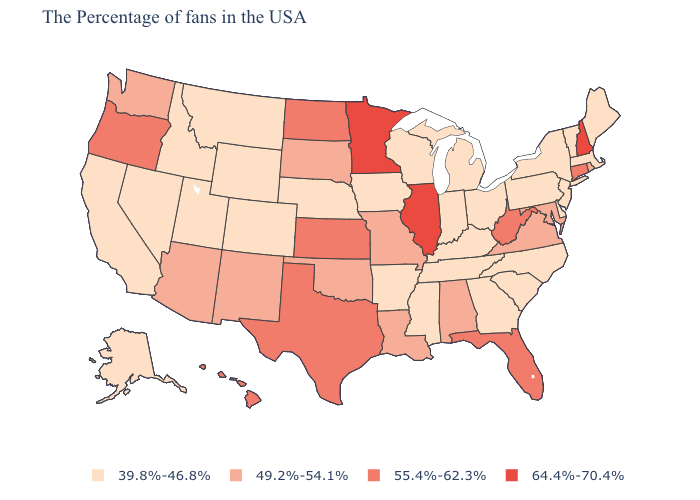Does Vermont have the lowest value in the Northeast?
Quick response, please. Yes. Name the states that have a value in the range 39.8%-46.8%?
Concise answer only. Maine, Massachusetts, Vermont, New York, New Jersey, Delaware, Pennsylvania, North Carolina, South Carolina, Ohio, Georgia, Michigan, Kentucky, Indiana, Tennessee, Wisconsin, Mississippi, Arkansas, Iowa, Nebraska, Wyoming, Colorado, Utah, Montana, Idaho, Nevada, California, Alaska. Which states have the highest value in the USA?
Short answer required. New Hampshire, Illinois, Minnesota. Does New Hampshire have the highest value in the USA?
Short answer required. Yes. Does Illinois have the highest value in the USA?
Keep it brief. Yes. Among the states that border Oregon , does Nevada have the highest value?
Be succinct. No. What is the lowest value in the Northeast?
Be succinct. 39.8%-46.8%. What is the highest value in states that border Nebraska?
Keep it brief. 55.4%-62.3%. Name the states that have a value in the range 49.2%-54.1%?
Keep it brief. Rhode Island, Maryland, Virginia, Alabama, Louisiana, Missouri, Oklahoma, South Dakota, New Mexico, Arizona, Washington. What is the lowest value in states that border Maryland?
Write a very short answer. 39.8%-46.8%. Which states have the lowest value in the South?
Concise answer only. Delaware, North Carolina, South Carolina, Georgia, Kentucky, Tennessee, Mississippi, Arkansas. Which states have the lowest value in the USA?
Short answer required. Maine, Massachusetts, Vermont, New York, New Jersey, Delaware, Pennsylvania, North Carolina, South Carolina, Ohio, Georgia, Michigan, Kentucky, Indiana, Tennessee, Wisconsin, Mississippi, Arkansas, Iowa, Nebraska, Wyoming, Colorado, Utah, Montana, Idaho, Nevada, California, Alaska. Among the states that border Louisiana , does Texas have the highest value?
Short answer required. Yes. What is the value of Indiana?
Write a very short answer. 39.8%-46.8%. Among the states that border Mississippi , does Alabama have the highest value?
Answer briefly. Yes. 